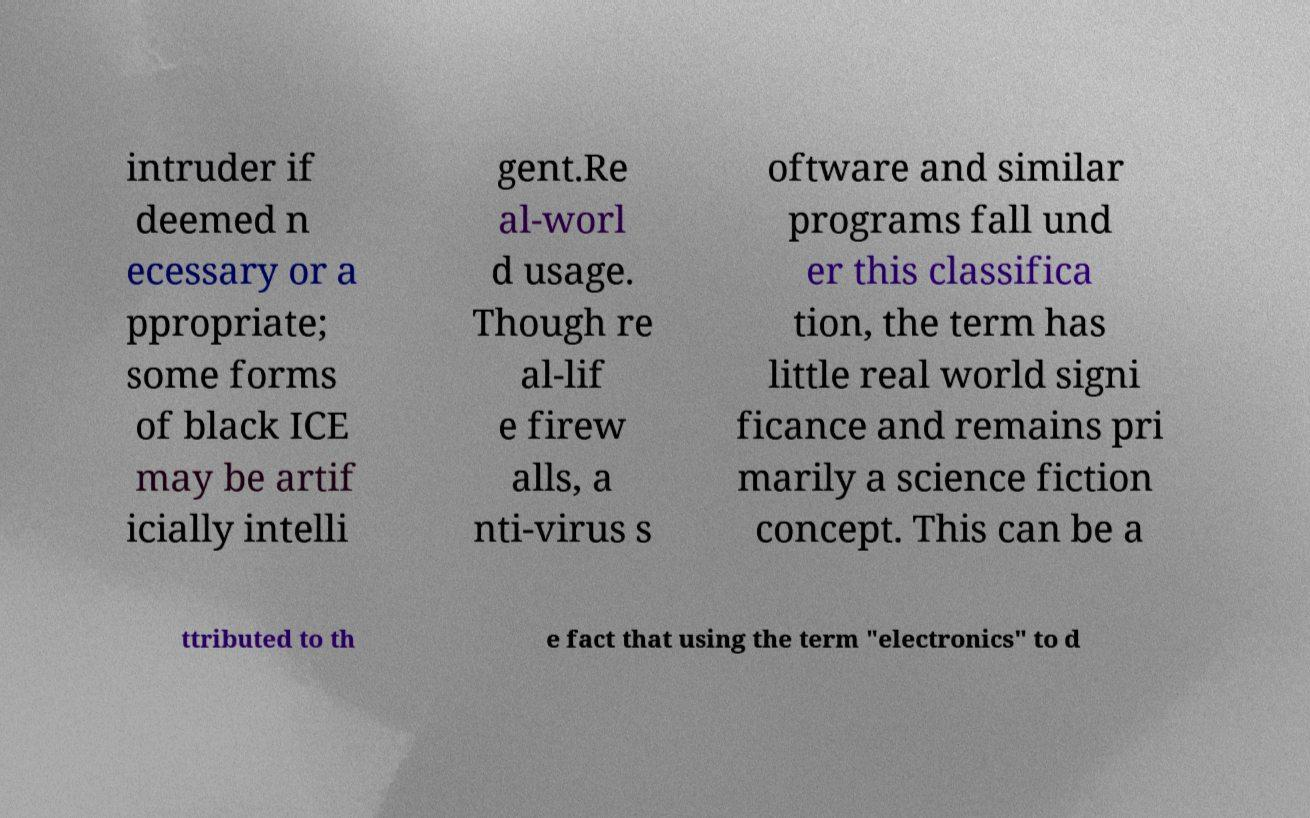Could you extract and type out the text from this image? intruder if deemed n ecessary or a ppropriate; some forms of black ICE may be artif icially intelli gent.Re al-worl d usage. Though re al-lif e firew alls, a nti-virus s oftware and similar programs fall und er this classifica tion, the term has little real world signi ficance and remains pri marily a science fiction concept. This can be a ttributed to th e fact that using the term "electronics" to d 